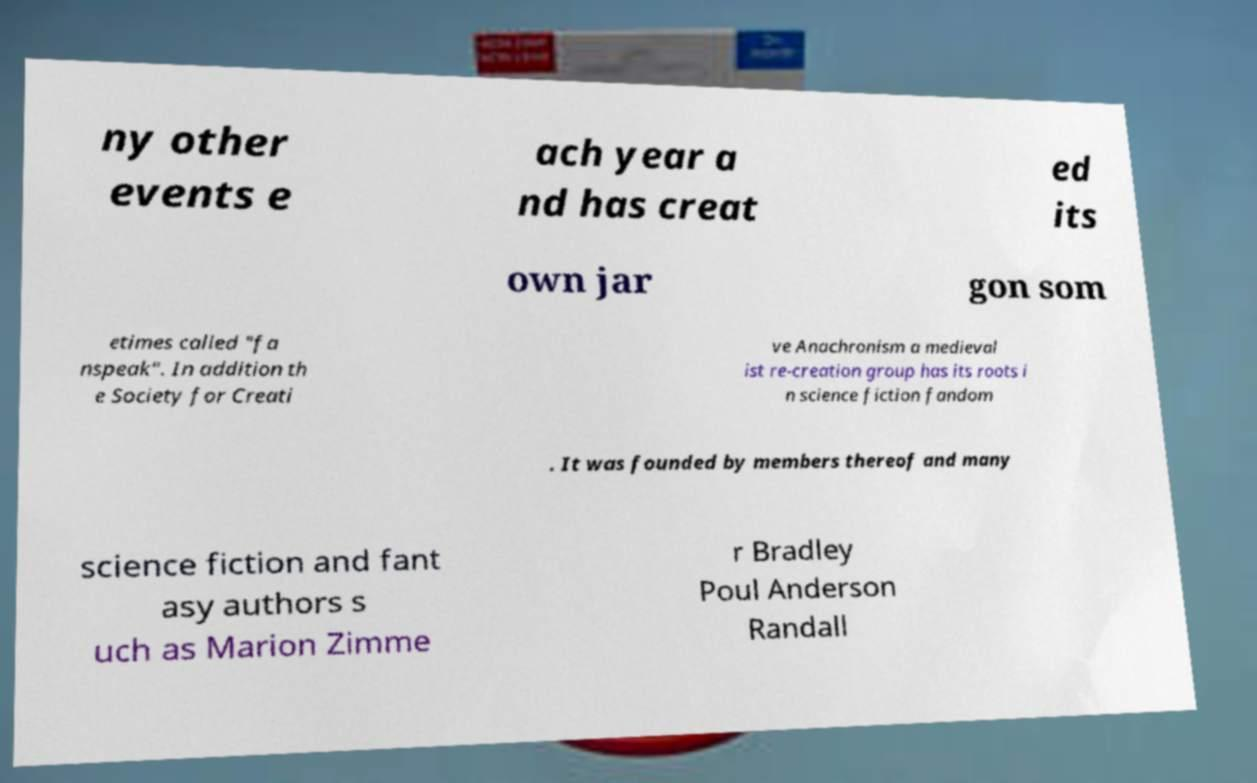There's text embedded in this image that I need extracted. Can you transcribe it verbatim? ny other events e ach year a nd has creat ed its own jar gon som etimes called "fa nspeak". In addition th e Society for Creati ve Anachronism a medieval ist re-creation group has its roots i n science fiction fandom . It was founded by members thereof and many science fiction and fant asy authors s uch as Marion Zimme r Bradley Poul Anderson Randall 